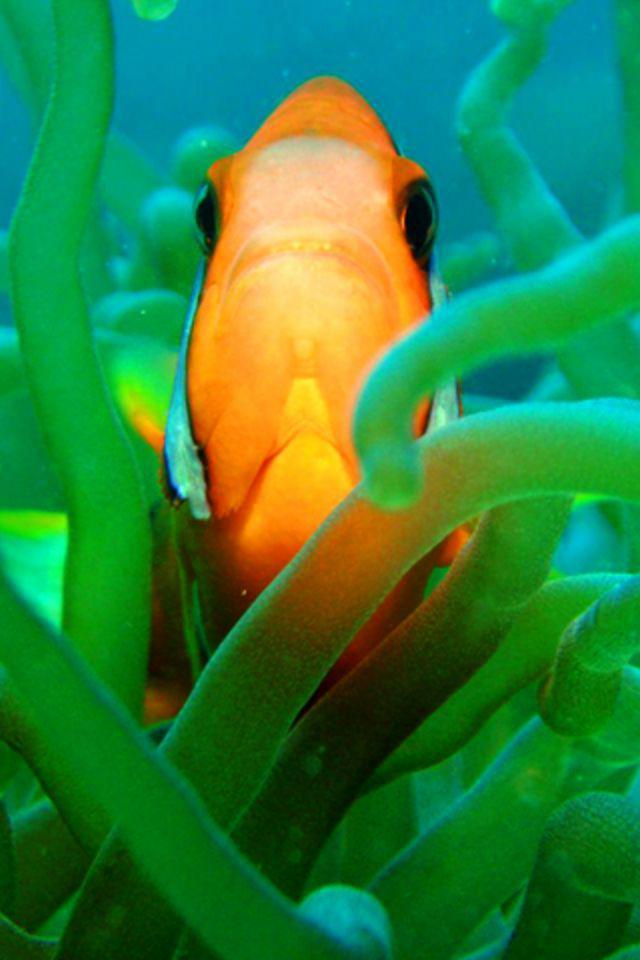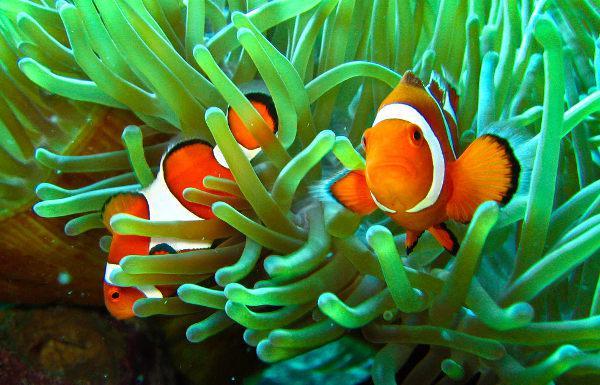The first image is the image on the left, the second image is the image on the right. Evaluate the accuracy of this statement regarding the images: "The right image shows more than one clown fish swimming among tube shapes.". Is it true? Answer yes or no. Yes. The first image is the image on the left, the second image is the image on the right. Evaluate the accuracy of this statement regarding the images: "There is exactly one fish in the image on the right.". Is it true? Answer yes or no. No. 